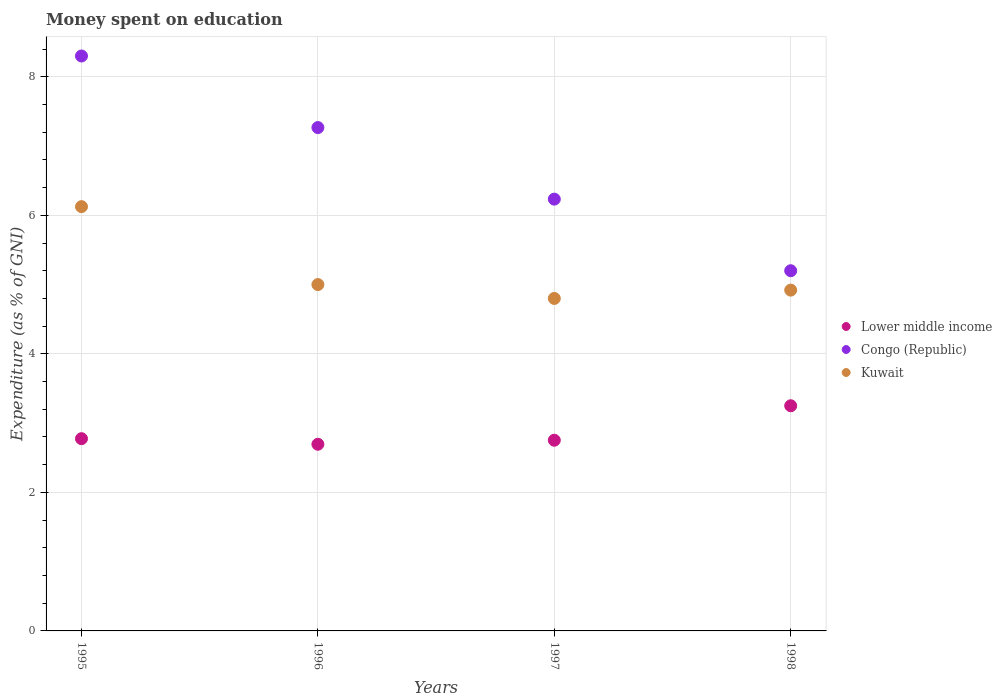How many different coloured dotlines are there?
Your answer should be very brief. 3. What is the amount of money spent on education in Congo (Republic) in 1998?
Keep it short and to the point. 5.2. Across all years, what is the maximum amount of money spent on education in Kuwait?
Ensure brevity in your answer.  6.13. In which year was the amount of money spent on education in Congo (Republic) maximum?
Ensure brevity in your answer.  1995. What is the total amount of money spent on education in Kuwait in the graph?
Provide a short and direct response. 20.85. What is the difference between the amount of money spent on education in Kuwait in 1996 and that in 1997?
Keep it short and to the point. 0.2. What is the difference between the amount of money spent on education in Congo (Republic) in 1998 and the amount of money spent on education in Lower middle income in 1997?
Ensure brevity in your answer.  2.45. What is the average amount of money spent on education in Lower middle income per year?
Your answer should be very brief. 2.87. In the year 1998, what is the difference between the amount of money spent on education in Kuwait and amount of money spent on education in Congo (Republic)?
Provide a short and direct response. -0.28. What is the ratio of the amount of money spent on education in Lower middle income in 1996 to that in 1997?
Provide a succinct answer. 0.98. Is the difference between the amount of money spent on education in Kuwait in 1995 and 1997 greater than the difference between the amount of money spent on education in Congo (Republic) in 1995 and 1997?
Ensure brevity in your answer.  No. What is the difference between the highest and the second highest amount of money spent on education in Congo (Republic)?
Offer a terse response. 1.03. What is the difference between the highest and the lowest amount of money spent on education in Congo (Republic)?
Ensure brevity in your answer.  3.1. Is the sum of the amount of money spent on education in Kuwait in 1995 and 1998 greater than the maximum amount of money spent on education in Congo (Republic) across all years?
Provide a succinct answer. Yes. Is it the case that in every year, the sum of the amount of money spent on education in Lower middle income and amount of money spent on education in Congo (Republic)  is greater than the amount of money spent on education in Kuwait?
Your answer should be very brief. Yes. Does the amount of money spent on education in Kuwait monotonically increase over the years?
Your answer should be very brief. No. Is the amount of money spent on education in Lower middle income strictly greater than the amount of money spent on education in Kuwait over the years?
Your answer should be very brief. No. How many dotlines are there?
Your answer should be very brief. 3. Are the values on the major ticks of Y-axis written in scientific E-notation?
Ensure brevity in your answer.  No. Does the graph contain any zero values?
Ensure brevity in your answer.  No. Does the graph contain grids?
Provide a succinct answer. Yes. Where does the legend appear in the graph?
Your answer should be very brief. Center right. How many legend labels are there?
Keep it short and to the point. 3. What is the title of the graph?
Give a very brief answer. Money spent on education. Does "Least developed countries" appear as one of the legend labels in the graph?
Provide a succinct answer. No. What is the label or title of the Y-axis?
Provide a short and direct response. Expenditure (as % of GNI). What is the Expenditure (as % of GNI) in Lower middle income in 1995?
Provide a succinct answer. 2.78. What is the Expenditure (as % of GNI) of Kuwait in 1995?
Your answer should be compact. 6.13. What is the Expenditure (as % of GNI) of Lower middle income in 1996?
Offer a very short reply. 2.69. What is the Expenditure (as % of GNI) of Congo (Republic) in 1996?
Your response must be concise. 7.27. What is the Expenditure (as % of GNI) in Lower middle income in 1997?
Provide a succinct answer. 2.75. What is the Expenditure (as % of GNI) of Congo (Republic) in 1997?
Offer a very short reply. 6.23. What is the Expenditure (as % of GNI) in Lower middle income in 1998?
Your answer should be compact. 3.25. What is the Expenditure (as % of GNI) in Kuwait in 1998?
Offer a very short reply. 4.92. Across all years, what is the maximum Expenditure (as % of GNI) in Lower middle income?
Offer a terse response. 3.25. Across all years, what is the maximum Expenditure (as % of GNI) of Kuwait?
Offer a terse response. 6.13. Across all years, what is the minimum Expenditure (as % of GNI) of Lower middle income?
Your answer should be very brief. 2.69. Across all years, what is the minimum Expenditure (as % of GNI) of Congo (Republic)?
Provide a succinct answer. 5.2. What is the total Expenditure (as % of GNI) in Lower middle income in the graph?
Your answer should be very brief. 11.47. What is the total Expenditure (as % of GNI) in Kuwait in the graph?
Give a very brief answer. 20.84. What is the difference between the Expenditure (as % of GNI) of Lower middle income in 1995 and that in 1996?
Provide a short and direct response. 0.08. What is the difference between the Expenditure (as % of GNI) in Lower middle income in 1995 and that in 1997?
Keep it short and to the point. 0.02. What is the difference between the Expenditure (as % of GNI) of Congo (Republic) in 1995 and that in 1997?
Your answer should be compact. 2.07. What is the difference between the Expenditure (as % of GNI) of Kuwait in 1995 and that in 1997?
Your answer should be very brief. 1.32. What is the difference between the Expenditure (as % of GNI) in Lower middle income in 1995 and that in 1998?
Provide a succinct answer. -0.48. What is the difference between the Expenditure (as % of GNI) in Kuwait in 1995 and that in 1998?
Give a very brief answer. 1.21. What is the difference between the Expenditure (as % of GNI) in Lower middle income in 1996 and that in 1997?
Keep it short and to the point. -0.06. What is the difference between the Expenditure (as % of GNI) of Congo (Republic) in 1996 and that in 1997?
Your answer should be very brief. 1.03. What is the difference between the Expenditure (as % of GNI) in Kuwait in 1996 and that in 1997?
Your answer should be very brief. 0.2. What is the difference between the Expenditure (as % of GNI) of Lower middle income in 1996 and that in 1998?
Offer a terse response. -0.56. What is the difference between the Expenditure (as % of GNI) in Congo (Republic) in 1996 and that in 1998?
Your response must be concise. 2.07. What is the difference between the Expenditure (as % of GNI) in Kuwait in 1996 and that in 1998?
Make the answer very short. 0.08. What is the difference between the Expenditure (as % of GNI) in Lower middle income in 1997 and that in 1998?
Keep it short and to the point. -0.5. What is the difference between the Expenditure (as % of GNI) of Kuwait in 1997 and that in 1998?
Give a very brief answer. -0.12. What is the difference between the Expenditure (as % of GNI) in Lower middle income in 1995 and the Expenditure (as % of GNI) in Congo (Republic) in 1996?
Offer a terse response. -4.49. What is the difference between the Expenditure (as % of GNI) in Lower middle income in 1995 and the Expenditure (as % of GNI) in Kuwait in 1996?
Your response must be concise. -2.22. What is the difference between the Expenditure (as % of GNI) of Congo (Republic) in 1995 and the Expenditure (as % of GNI) of Kuwait in 1996?
Offer a very short reply. 3.3. What is the difference between the Expenditure (as % of GNI) of Lower middle income in 1995 and the Expenditure (as % of GNI) of Congo (Republic) in 1997?
Offer a very short reply. -3.46. What is the difference between the Expenditure (as % of GNI) in Lower middle income in 1995 and the Expenditure (as % of GNI) in Kuwait in 1997?
Provide a short and direct response. -2.02. What is the difference between the Expenditure (as % of GNI) of Congo (Republic) in 1995 and the Expenditure (as % of GNI) of Kuwait in 1997?
Your answer should be very brief. 3.5. What is the difference between the Expenditure (as % of GNI) in Lower middle income in 1995 and the Expenditure (as % of GNI) in Congo (Republic) in 1998?
Provide a short and direct response. -2.42. What is the difference between the Expenditure (as % of GNI) of Lower middle income in 1995 and the Expenditure (as % of GNI) of Kuwait in 1998?
Your response must be concise. -2.14. What is the difference between the Expenditure (as % of GNI) of Congo (Republic) in 1995 and the Expenditure (as % of GNI) of Kuwait in 1998?
Your response must be concise. 3.38. What is the difference between the Expenditure (as % of GNI) of Lower middle income in 1996 and the Expenditure (as % of GNI) of Congo (Republic) in 1997?
Offer a very short reply. -3.54. What is the difference between the Expenditure (as % of GNI) in Lower middle income in 1996 and the Expenditure (as % of GNI) in Kuwait in 1997?
Make the answer very short. -2.11. What is the difference between the Expenditure (as % of GNI) in Congo (Republic) in 1996 and the Expenditure (as % of GNI) in Kuwait in 1997?
Your response must be concise. 2.47. What is the difference between the Expenditure (as % of GNI) of Lower middle income in 1996 and the Expenditure (as % of GNI) of Congo (Republic) in 1998?
Offer a very short reply. -2.51. What is the difference between the Expenditure (as % of GNI) in Lower middle income in 1996 and the Expenditure (as % of GNI) in Kuwait in 1998?
Ensure brevity in your answer.  -2.23. What is the difference between the Expenditure (as % of GNI) in Congo (Republic) in 1996 and the Expenditure (as % of GNI) in Kuwait in 1998?
Your response must be concise. 2.35. What is the difference between the Expenditure (as % of GNI) of Lower middle income in 1997 and the Expenditure (as % of GNI) of Congo (Republic) in 1998?
Your answer should be very brief. -2.45. What is the difference between the Expenditure (as % of GNI) in Lower middle income in 1997 and the Expenditure (as % of GNI) in Kuwait in 1998?
Give a very brief answer. -2.17. What is the difference between the Expenditure (as % of GNI) of Congo (Republic) in 1997 and the Expenditure (as % of GNI) of Kuwait in 1998?
Ensure brevity in your answer.  1.31. What is the average Expenditure (as % of GNI) of Lower middle income per year?
Ensure brevity in your answer.  2.87. What is the average Expenditure (as % of GNI) in Congo (Republic) per year?
Offer a very short reply. 6.75. What is the average Expenditure (as % of GNI) in Kuwait per year?
Provide a short and direct response. 5.21. In the year 1995, what is the difference between the Expenditure (as % of GNI) of Lower middle income and Expenditure (as % of GNI) of Congo (Republic)?
Ensure brevity in your answer.  -5.52. In the year 1995, what is the difference between the Expenditure (as % of GNI) in Lower middle income and Expenditure (as % of GNI) in Kuwait?
Ensure brevity in your answer.  -3.35. In the year 1995, what is the difference between the Expenditure (as % of GNI) in Congo (Republic) and Expenditure (as % of GNI) in Kuwait?
Offer a very short reply. 2.17. In the year 1996, what is the difference between the Expenditure (as % of GNI) of Lower middle income and Expenditure (as % of GNI) of Congo (Republic)?
Provide a short and direct response. -4.57. In the year 1996, what is the difference between the Expenditure (as % of GNI) of Lower middle income and Expenditure (as % of GNI) of Kuwait?
Make the answer very short. -2.31. In the year 1996, what is the difference between the Expenditure (as % of GNI) in Congo (Republic) and Expenditure (as % of GNI) in Kuwait?
Offer a very short reply. 2.27. In the year 1997, what is the difference between the Expenditure (as % of GNI) of Lower middle income and Expenditure (as % of GNI) of Congo (Republic)?
Provide a short and direct response. -3.48. In the year 1997, what is the difference between the Expenditure (as % of GNI) of Lower middle income and Expenditure (as % of GNI) of Kuwait?
Ensure brevity in your answer.  -2.05. In the year 1997, what is the difference between the Expenditure (as % of GNI) in Congo (Republic) and Expenditure (as % of GNI) in Kuwait?
Provide a succinct answer. 1.43. In the year 1998, what is the difference between the Expenditure (as % of GNI) of Lower middle income and Expenditure (as % of GNI) of Congo (Republic)?
Your answer should be compact. -1.95. In the year 1998, what is the difference between the Expenditure (as % of GNI) in Lower middle income and Expenditure (as % of GNI) in Kuwait?
Offer a terse response. -1.67. In the year 1998, what is the difference between the Expenditure (as % of GNI) of Congo (Republic) and Expenditure (as % of GNI) of Kuwait?
Your response must be concise. 0.28. What is the ratio of the Expenditure (as % of GNI) in Lower middle income in 1995 to that in 1996?
Provide a short and direct response. 1.03. What is the ratio of the Expenditure (as % of GNI) of Congo (Republic) in 1995 to that in 1996?
Your answer should be compact. 1.14. What is the ratio of the Expenditure (as % of GNI) of Kuwait in 1995 to that in 1996?
Give a very brief answer. 1.23. What is the ratio of the Expenditure (as % of GNI) of Lower middle income in 1995 to that in 1997?
Your answer should be compact. 1.01. What is the ratio of the Expenditure (as % of GNI) of Congo (Republic) in 1995 to that in 1997?
Offer a very short reply. 1.33. What is the ratio of the Expenditure (as % of GNI) of Kuwait in 1995 to that in 1997?
Your answer should be very brief. 1.28. What is the ratio of the Expenditure (as % of GNI) in Lower middle income in 1995 to that in 1998?
Make the answer very short. 0.85. What is the ratio of the Expenditure (as % of GNI) of Congo (Republic) in 1995 to that in 1998?
Your answer should be very brief. 1.6. What is the ratio of the Expenditure (as % of GNI) of Kuwait in 1995 to that in 1998?
Provide a succinct answer. 1.24. What is the ratio of the Expenditure (as % of GNI) of Lower middle income in 1996 to that in 1997?
Offer a terse response. 0.98. What is the ratio of the Expenditure (as % of GNI) of Congo (Republic) in 1996 to that in 1997?
Provide a short and direct response. 1.17. What is the ratio of the Expenditure (as % of GNI) in Kuwait in 1996 to that in 1997?
Offer a very short reply. 1.04. What is the ratio of the Expenditure (as % of GNI) in Lower middle income in 1996 to that in 1998?
Ensure brevity in your answer.  0.83. What is the ratio of the Expenditure (as % of GNI) of Congo (Republic) in 1996 to that in 1998?
Provide a succinct answer. 1.4. What is the ratio of the Expenditure (as % of GNI) in Kuwait in 1996 to that in 1998?
Your answer should be compact. 1.02. What is the ratio of the Expenditure (as % of GNI) of Lower middle income in 1997 to that in 1998?
Offer a terse response. 0.85. What is the ratio of the Expenditure (as % of GNI) of Congo (Republic) in 1997 to that in 1998?
Offer a terse response. 1.2. What is the ratio of the Expenditure (as % of GNI) of Kuwait in 1997 to that in 1998?
Offer a terse response. 0.98. What is the difference between the highest and the second highest Expenditure (as % of GNI) in Lower middle income?
Offer a very short reply. 0.48. What is the difference between the highest and the second highest Expenditure (as % of GNI) in Congo (Republic)?
Ensure brevity in your answer.  1.03. What is the difference between the highest and the lowest Expenditure (as % of GNI) in Lower middle income?
Your response must be concise. 0.56. What is the difference between the highest and the lowest Expenditure (as % of GNI) of Congo (Republic)?
Provide a short and direct response. 3.1. What is the difference between the highest and the lowest Expenditure (as % of GNI) in Kuwait?
Your response must be concise. 1.32. 